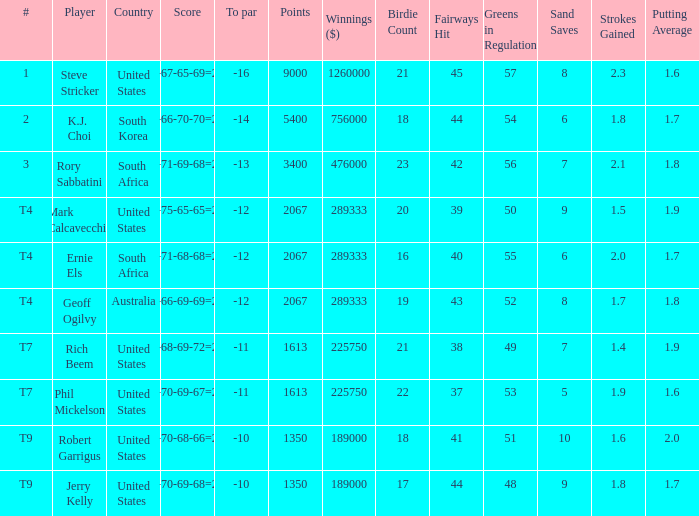Name the number of points for south korea 1.0. 